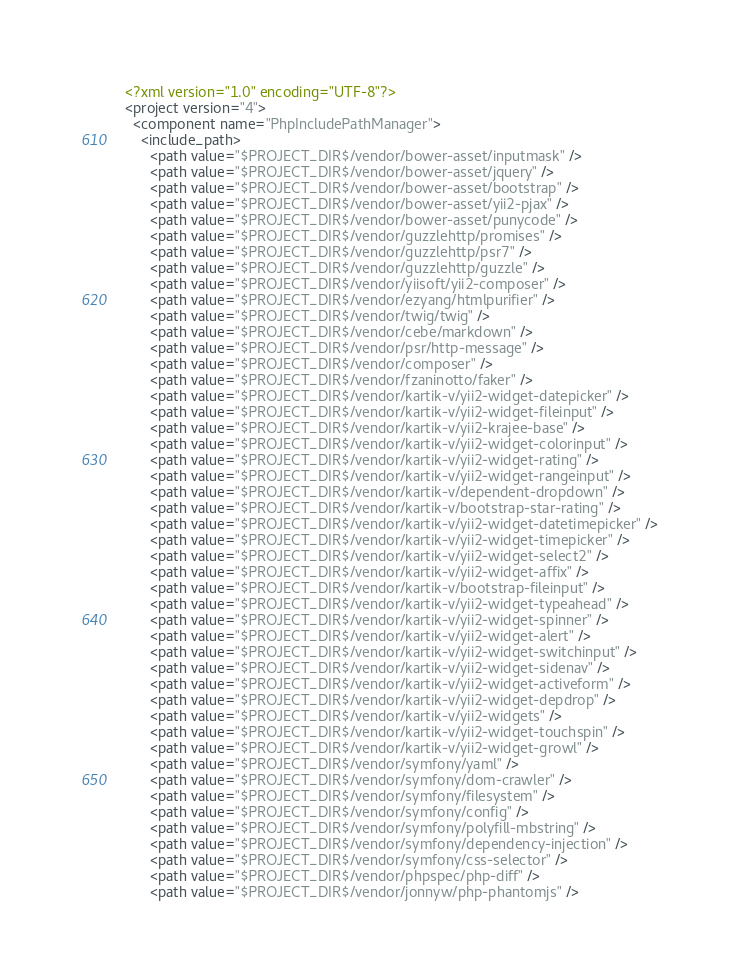<code> <loc_0><loc_0><loc_500><loc_500><_XML_><?xml version="1.0" encoding="UTF-8"?>
<project version="4">
  <component name="PhpIncludePathManager">
    <include_path>
      <path value="$PROJECT_DIR$/vendor/bower-asset/inputmask" />
      <path value="$PROJECT_DIR$/vendor/bower-asset/jquery" />
      <path value="$PROJECT_DIR$/vendor/bower-asset/bootstrap" />
      <path value="$PROJECT_DIR$/vendor/bower-asset/yii2-pjax" />
      <path value="$PROJECT_DIR$/vendor/bower-asset/punycode" />
      <path value="$PROJECT_DIR$/vendor/guzzlehttp/promises" />
      <path value="$PROJECT_DIR$/vendor/guzzlehttp/psr7" />
      <path value="$PROJECT_DIR$/vendor/guzzlehttp/guzzle" />
      <path value="$PROJECT_DIR$/vendor/yiisoft/yii2-composer" />
      <path value="$PROJECT_DIR$/vendor/ezyang/htmlpurifier" />
      <path value="$PROJECT_DIR$/vendor/twig/twig" />
      <path value="$PROJECT_DIR$/vendor/cebe/markdown" />
      <path value="$PROJECT_DIR$/vendor/psr/http-message" />
      <path value="$PROJECT_DIR$/vendor/composer" />
      <path value="$PROJECT_DIR$/vendor/fzaninotto/faker" />
      <path value="$PROJECT_DIR$/vendor/kartik-v/yii2-widget-datepicker" />
      <path value="$PROJECT_DIR$/vendor/kartik-v/yii2-widget-fileinput" />
      <path value="$PROJECT_DIR$/vendor/kartik-v/yii2-krajee-base" />
      <path value="$PROJECT_DIR$/vendor/kartik-v/yii2-widget-colorinput" />
      <path value="$PROJECT_DIR$/vendor/kartik-v/yii2-widget-rating" />
      <path value="$PROJECT_DIR$/vendor/kartik-v/yii2-widget-rangeinput" />
      <path value="$PROJECT_DIR$/vendor/kartik-v/dependent-dropdown" />
      <path value="$PROJECT_DIR$/vendor/kartik-v/bootstrap-star-rating" />
      <path value="$PROJECT_DIR$/vendor/kartik-v/yii2-widget-datetimepicker" />
      <path value="$PROJECT_DIR$/vendor/kartik-v/yii2-widget-timepicker" />
      <path value="$PROJECT_DIR$/vendor/kartik-v/yii2-widget-select2" />
      <path value="$PROJECT_DIR$/vendor/kartik-v/yii2-widget-affix" />
      <path value="$PROJECT_DIR$/vendor/kartik-v/bootstrap-fileinput" />
      <path value="$PROJECT_DIR$/vendor/kartik-v/yii2-widget-typeahead" />
      <path value="$PROJECT_DIR$/vendor/kartik-v/yii2-widget-spinner" />
      <path value="$PROJECT_DIR$/vendor/kartik-v/yii2-widget-alert" />
      <path value="$PROJECT_DIR$/vendor/kartik-v/yii2-widget-switchinput" />
      <path value="$PROJECT_DIR$/vendor/kartik-v/yii2-widget-sidenav" />
      <path value="$PROJECT_DIR$/vendor/kartik-v/yii2-widget-activeform" />
      <path value="$PROJECT_DIR$/vendor/kartik-v/yii2-widget-depdrop" />
      <path value="$PROJECT_DIR$/vendor/kartik-v/yii2-widgets" />
      <path value="$PROJECT_DIR$/vendor/kartik-v/yii2-widget-touchspin" />
      <path value="$PROJECT_DIR$/vendor/kartik-v/yii2-widget-growl" />
      <path value="$PROJECT_DIR$/vendor/symfony/yaml" />
      <path value="$PROJECT_DIR$/vendor/symfony/dom-crawler" />
      <path value="$PROJECT_DIR$/vendor/symfony/filesystem" />
      <path value="$PROJECT_DIR$/vendor/symfony/config" />
      <path value="$PROJECT_DIR$/vendor/symfony/polyfill-mbstring" />
      <path value="$PROJECT_DIR$/vendor/symfony/dependency-injection" />
      <path value="$PROJECT_DIR$/vendor/symfony/css-selector" />
      <path value="$PROJECT_DIR$/vendor/phpspec/php-diff" />
      <path value="$PROJECT_DIR$/vendor/jonnyw/php-phantomjs" /></code> 